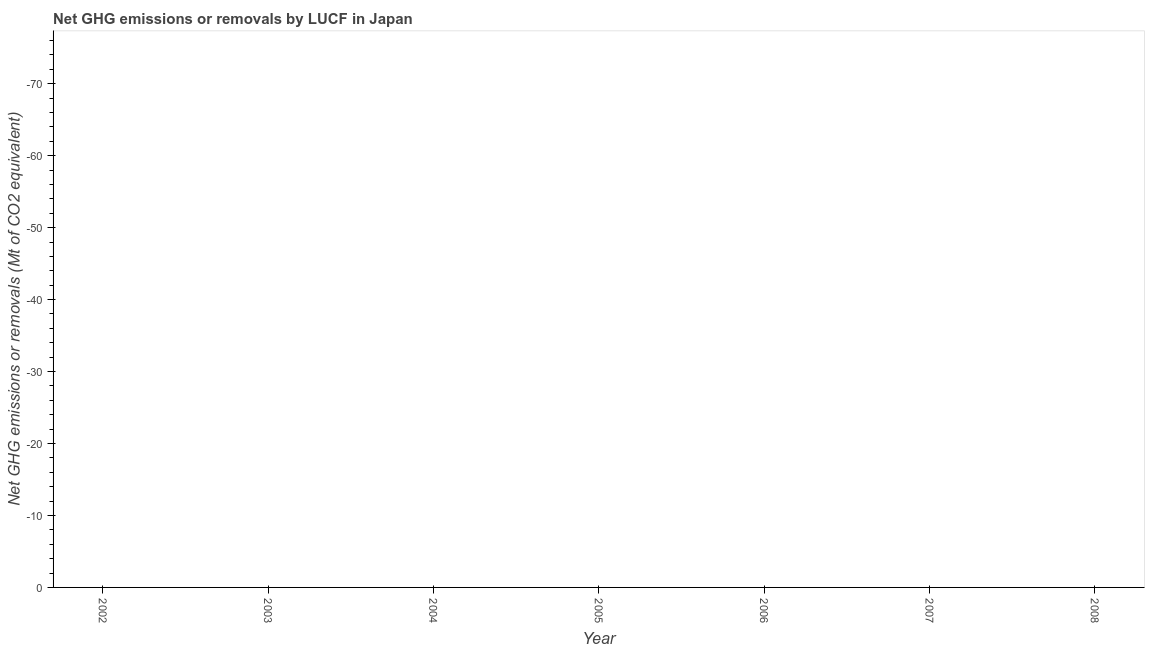What is the ghg net emissions or removals in 2006?
Make the answer very short. 0. Across all years, what is the minimum ghg net emissions or removals?
Give a very brief answer. 0. What is the sum of the ghg net emissions or removals?
Give a very brief answer. 0. What is the average ghg net emissions or removals per year?
Give a very brief answer. 0. What is the median ghg net emissions or removals?
Your answer should be very brief. 0. Does the ghg net emissions or removals monotonically increase over the years?
Keep it short and to the point. No. How many lines are there?
Offer a very short reply. 0. How many years are there in the graph?
Offer a terse response. 7. What is the difference between two consecutive major ticks on the Y-axis?
Give a very brief answer. 10. Are the values on the major ticks of Y-axis written in scientific E-notation?
Provide a short and direct response. No. Does the graph contain grids?
Your answer should be very brief. No. What is the title of the graph?
Keep it short and to the point. Net GHG emissions or removals by LUCF in Japan. What is the label or title of the Y-axis?
Keep it short and to the point. Net GHG emissions or removals (Mt of CO2 equivalent). What is the Net GHG emissions or removals (Mt of CO2 equivalent) of 2002?
Ensure brevity in your answer.  0. What is the Net GHG emissions or removals (Mt of CO2 equivalent) of 2005?
Offer a terse response. 0. What is the Net GHG emissions or removals (Mt of CO2 equivalent) in 2006?
Your answer should be very brief. 0. What is the Net GHG emissions or removals (Mt of CO2 equivalent) in 2007?
Keep it short and to the point. 0. What is the Net GHG emissions or removals (Mt of CO2 equivalent) in 2008?
Provide a short and direct response. 0. 